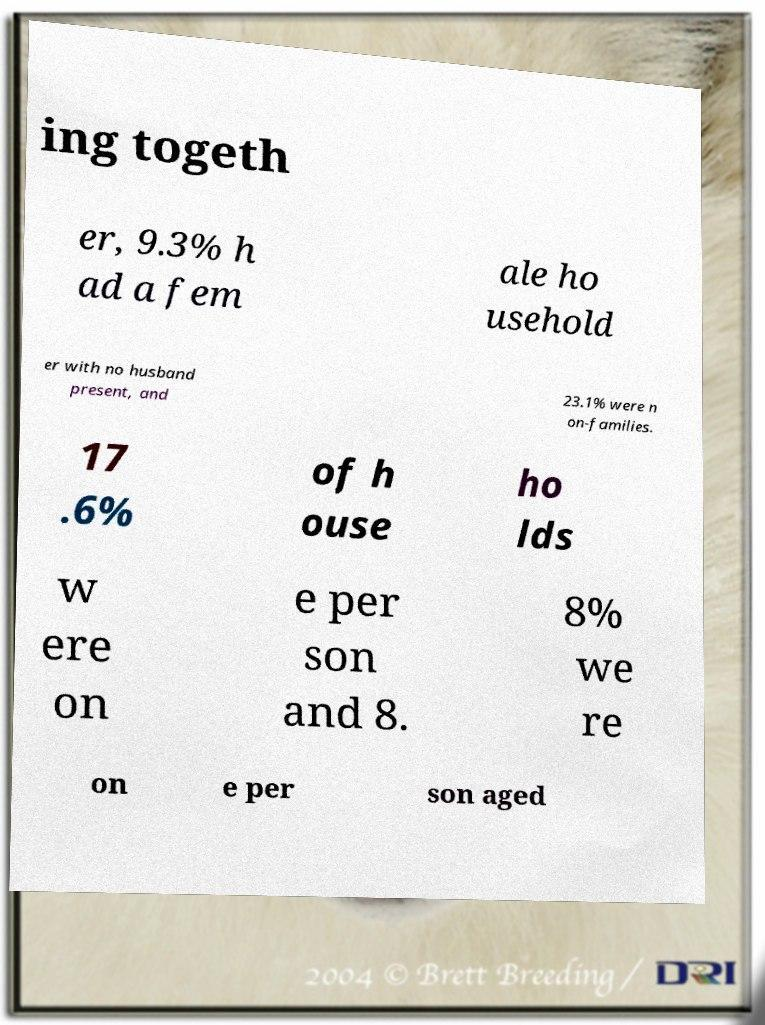I need the written content from this picture converted into text. Can you do that? ing togeth er, 9.3% h ad a fem ale ho usehold er with no husband present, and 23.1% were n on-families. 17 .6% of h ouse ho lds w ere on e per son and 8. 8% we re on e per son aged 